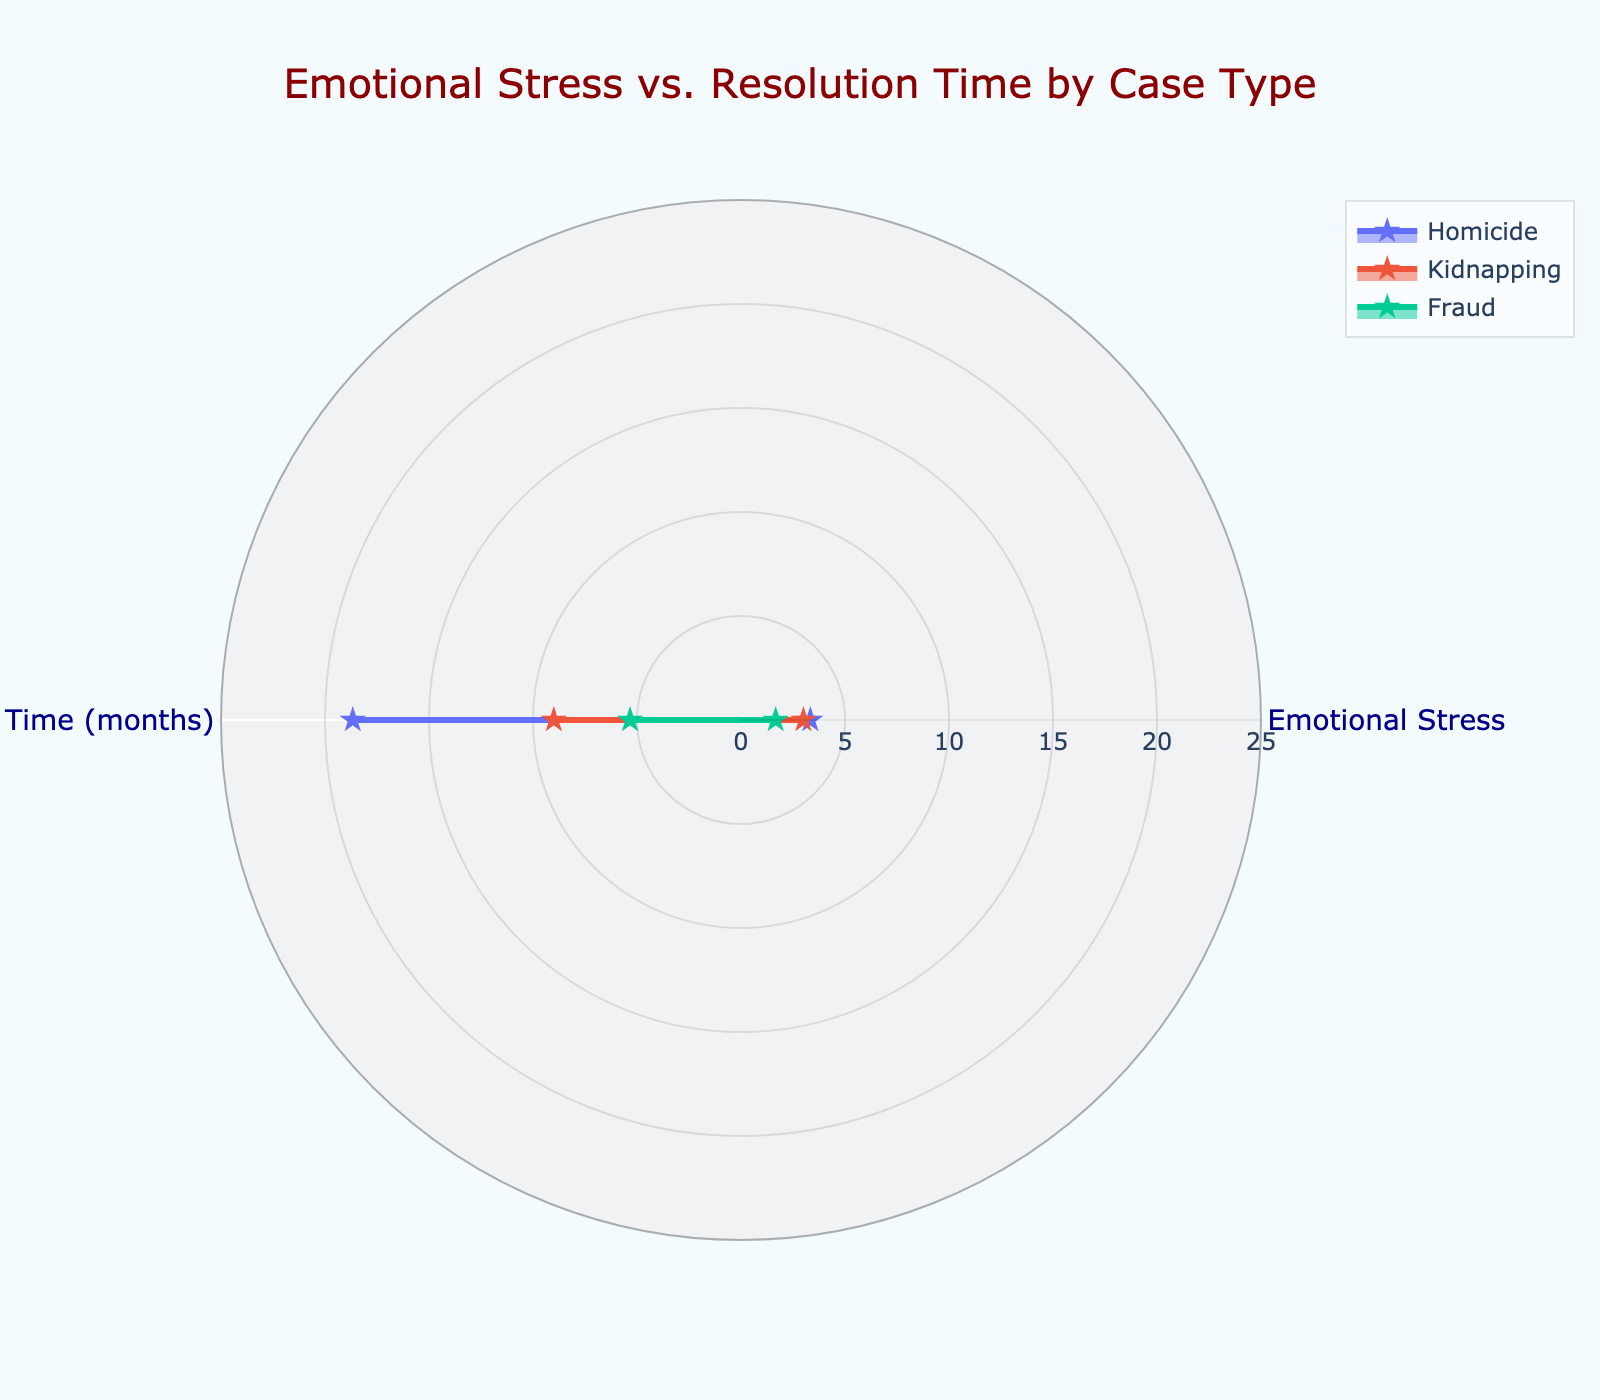What is the title of the radar chart? The title of the radar chart is displayed at the top center of the figure and gives an overview of the purpose of the chart.
Answer: Emotional Stress vs. Resolution Time by Case Type How many different case types are presented in the radar chart? Each case type is represented by a different trace on the radar chart. By counting the unique names in the legend, we find the number of case types.
Answer: Three Which case type has the highest average emotional stress? The average emotional stress for each case type is denoted by the distance from the center of the chart along the "Emotional Stress" axis. The legend helps identify the case type with the most extended distance on this axis.
Answer: Kidnapping What range does the radial axis represent for "Resolution Time (months)"? The radial axis range for "Resolution Time (months)" can be observed by reading the numerical values along the axis lines on the radar chart.
Answer: 0 to 25 Which case type has the lowest resolution time? The case type with the lowest resolution time will have the shortest distance from the center of the chart on the "Resolution Time (months)" axis. Use the legend to identify the corresponding trace.
Answer: Fraud Compare the average emotional stress of homicide to fraud cases. Which is higher? Compare the values on the "Emotional Stress" axis for the two case types to determine which has a higher average emotional stress.
Answer: Homicide What is the average resolution time of kidnapping cases? To find the average resolution time, locate the distance from the center on the "Resolution Time (months)" axis for the kidnapping trace and observe the numeric value.
Answer: 9 months How does the resolution time of homicide cases compare to the resolution time of fraud cases? Compare the distances from the center on the "Resolution Time (months)" axis for both homicide and fraud traces to see which has a longer or shorter resolution time.
Answer: Homicide has a higher resolution time Which case type balances moderate emotional stress and resolution time closely to the average for that case type? Analyze the traces on the radar chart to find the case type whose values for both emotional stress and resolution time are closest to the general average (mean) values on both axes.
Answer: Fraud 